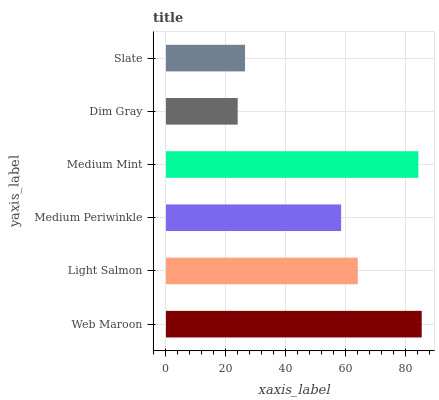Is Dim Gray the minimum?
Answer yes or no. Yes. Is Web Maroon the maximum?
Answer yes or no. Yes. Is Light Salmon the minimum?
Answer yes or no. No. Is Light Salmon the maximum?
Answer yes or no. No. Is Web Maroon greater than Light Salmon?
Answer yes or no. Yes. Is Light Salmon less than Web Maroon?
Answer yes or no. Yes. Is Light Salmon greater than Web Maroon?
Answer yes or no. No. Is Web Maroon less than Light Salmon?
Answer yes or no. No. Is Light Salmon the high median?
Answer yes or no. Yes. Is Medium Periwinkle the low median?
Answer yes or no. Yes. Is Medium Periwinkle the high median?
Answer yes or no. No. Is Light Salmon the low median?
Answer yes or no. No. 